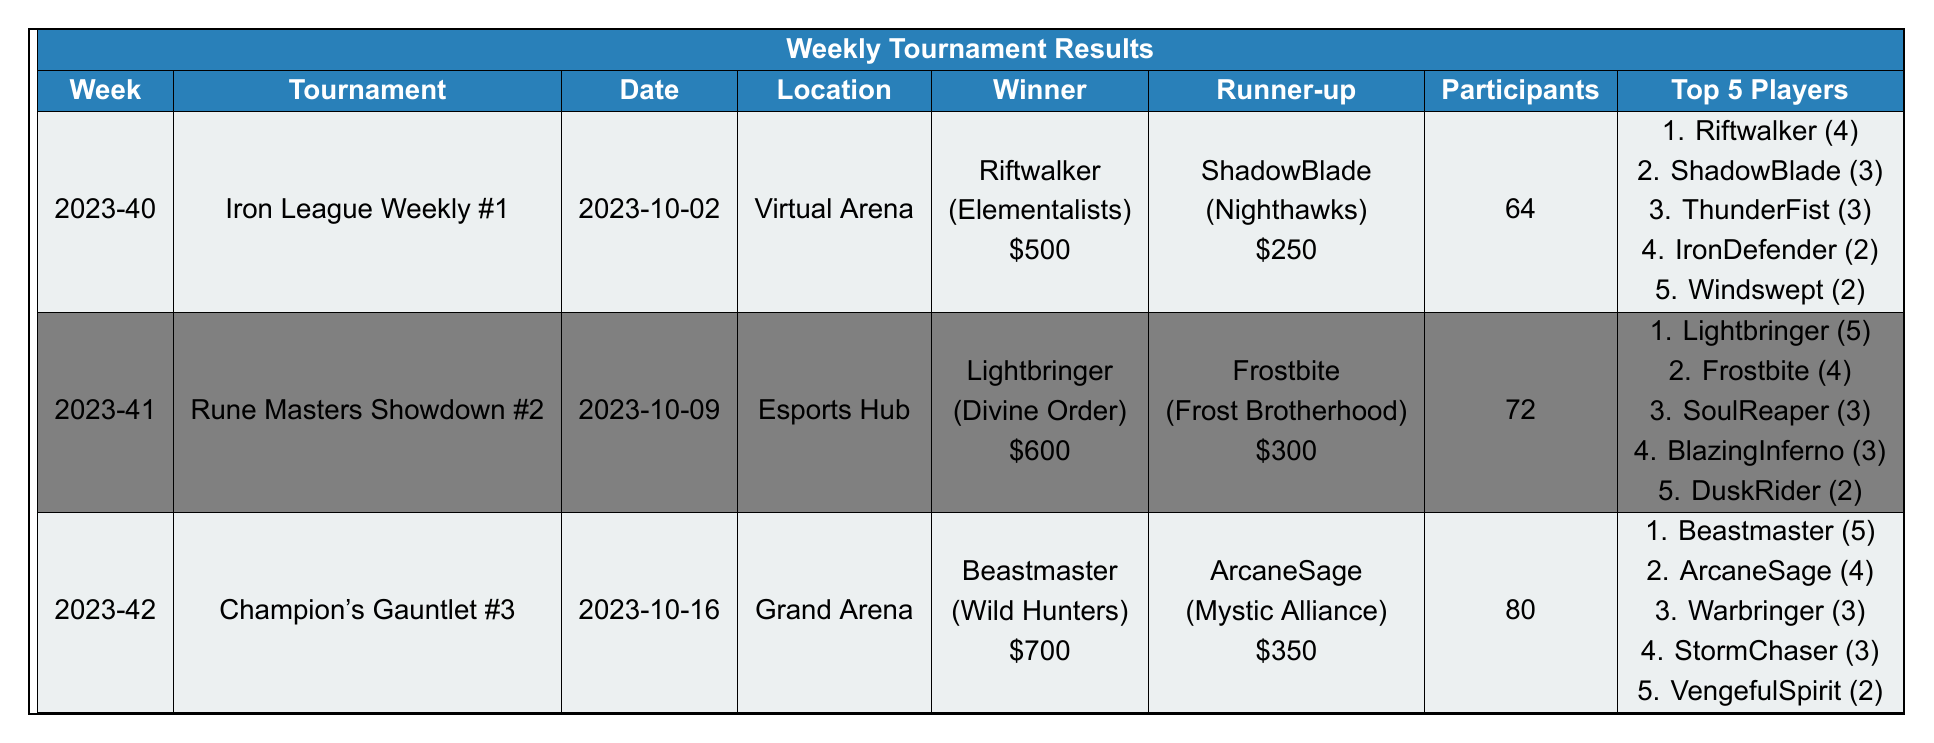What was the prize money for the winner of the Iron League Weekly #1? The winner, Riftwalker, received prize money of $500.
Answer: $500 Who finished in second place during the Rune Masters Showdown #2? The runner-up was Frostbite, who finished in second place.
Answer: Frostbite How many total participants were there in the Champion's Gauntlet #3? The total number of participants was 80.
Answer: 80 Which player had the highest score in the Iron League Weekly #1? Riftwalker had the highest score of 4 in that tournament.
Answer: Riftwalker What is the total prize money awarded to the winner of the Rune Masters Showdown #2 and the Champion's Gauntlet #3 combined? The prize money awarded was $600 for Rune Masters Showdown #2 and $700 for Champion's Gauntlet #3. Therefore, the total is $600 + $700 = $1300.
Answer: $1300 True or False: There were more participants in the Iron League Weekly #1 than in the Champion's Gauntlet #3. Iron League Weekly #1 had 64 participants while Champion's Gauntlet #3 had 80 participants, which means the statement is false.
Answer: False Who won a tournament in week 2023-41? Lightbringer won the Rune Masters Showdown #2 in week 2023-41.
Answer: Lightbringer If you combine the scores of the top 3 players from the Champion's Gauntlet #3, what is the total score? The top 3 players in that tournament scored 5 (Beastmaster) + 4 (ArcaneSage) + 3 (Warbringer), which totals 12.
Answer: 12 Which faction did the winner of the Iron League Weekly #1 belong to? The winner, Riftwalker, belonged to the Elementalists faction.
Answer: Elementalists Did any player score 3 points in both the Iron League Weekly #1 and the Rune Masters Showdown #2? Yes, ShadowBlade scored 3 points in Iron League Weekly #1, and SoulReaper scored 3 points in Rune Masters Showdown #2.
Answer: Yes Calculate the average number of participants across the three tournaments. The total number of participants is 64 (Iron League Weekly #1) + 72 (Rune Masters Showdown #2) + 80 (Champion's Gauntlet #3) = 216. With 3 tournaments, the average is 216 / 3 = 72.
Answer: 72 